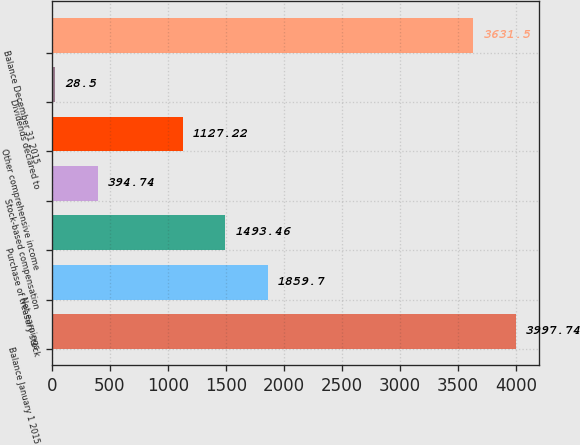Convert chart to OTSL. <chart><loc_0><loc_0><loc_500><loc_500><bar_chart><fcel>Balance January 1 2015<fcel>Net earnings<fcel>Purchase of treasury stock<fcel>Stock-based compensation<fcel>Other comprehensive income<fcel>Dividends declared to<fcel>Balance December 31 2015<nl><fcel>3997.74<fcel>1859.7<fcel>1493.46<fcel>394.74<fcel>1127.22<fcel>28.5<fcel>3631.5<nl></chart> 